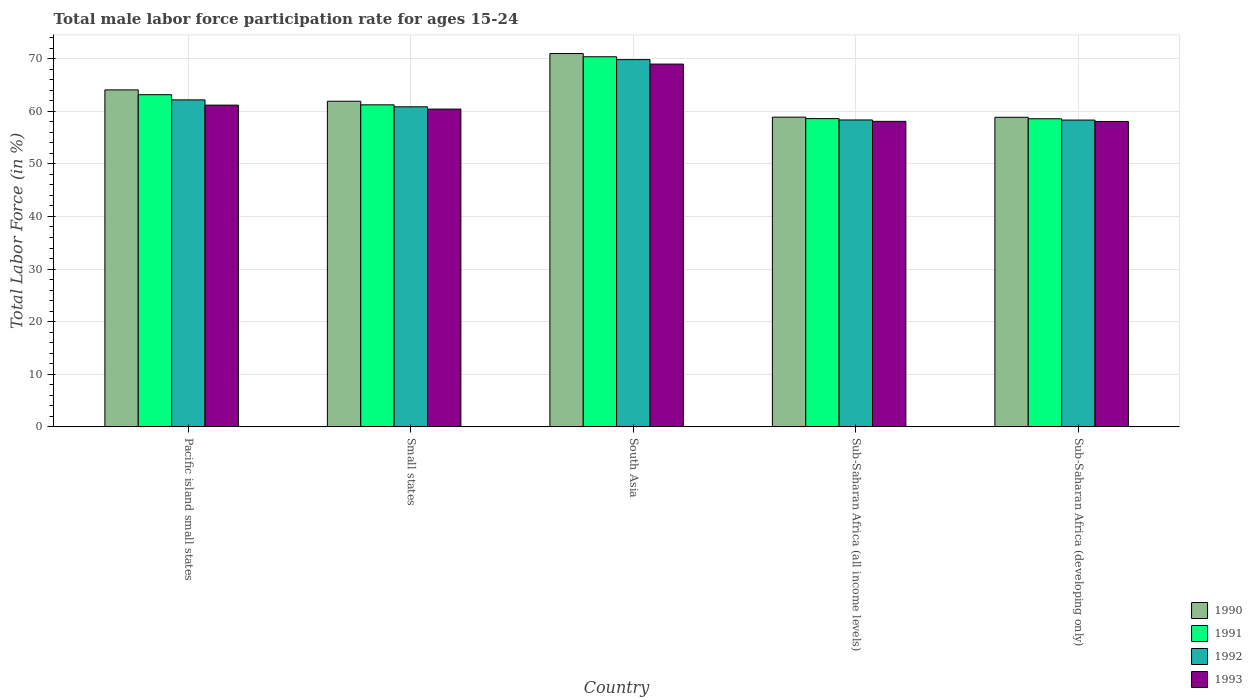How many different coloured bars are there?
Offer a very short reply. 4. Are the number of bars per tick equal to the number of legend labels?
Ensure brevity in your answer.  Yes. How many bars are there on the 5th tick from the left?
Provide a short and direct response. 4. What is the label of the 4th group of bars from the left?
Offer a terse response. Sub-Saharan Africa (all income levels). What is the male labor force participation rate in 1991 in Small states?
Offer a terse response. 61.22. Across all countries, what is the maximum male labor force participation rate in 1992?
Offer a terse response. 69.81. Across all countries, what is the minimum male labor force participation rate in 1991?
Offer a terse response. 58.57. In which country was the male labor force participation rate in 1992 maximum?
Your answer should be compact. South Asia. In which country was the male labor force participation rate in 1990 minimum?
Keep it short and to the point. Sub-Saharan Africa (developing only). What is the total male labor force participation rate in 1991 in the graph?
Offer a very short reply. 311.89. What is the difference between the male labor force participation rate in 1992 in Sub-Saharan Africa (all income levels) and that in Sub-Saharan Africa (developing only)?
Provide a succinct answer. 0.02. What is the difference between the male labor force participation rate in 1991 in South Asia and the male labor force participation rate in 1992 in Sub-Saharan Africa (developing only)?
Provide a short and direct response. 12.04. What is the average male labor force participation rate in 1992 per country?
Your answer should be compact. 61.89. What is the difference between the male labor force participation rate of/in 1990 and male labor force participation rate of/in 1992 in Pacific island small states?
Your answer should be compact. 1.9. What is the ratio of the male labor force participation rate in 1990 in Pacific island small states to that in Small states?
Provide a short and direct response. 1.03. What is the difference between the highest and the second highest male labor force participation rate in 1992?
Provide a short and direct response. -8.97. What is the difference between the highest and the lowest male labor force participation rate in 1992?
Keep it short and to the point. 11.49. Is the sum of the male labor force participation rate in 1991 in Sub-Saharan Africa (all income levels) and Sub-Saharan Africa (developing only) greater than the maximum male labor force participation rate in 1990 across all countries?
Your answer should be compact. Yes. Is it the case that in every country, the sum of the male labor force participation rate in 1990 and male labor force participation rate in 1991 is greater than the sum of male labor force participation rate in 1993 and male labor force participation rate in 1992?
Ensure brevity in your answer.  No. What does the 3rd bar from the right in Pacific island small states represents?
Your answer should be very brief. 1991. Is it the case that in every country, the sum of the male labor force participation rate in 1991 and male labor force participation rate in 1993 is greater than the male labor force participation rate in 1990?
Make the answer very short. Yes. How many bars are there?
Offer a terse response. 20. Does the graph contain grids?
Ensure brevity in your answer.  Yes. Where does the legend appear in the graph?
Provide a succinct answer. Bottom right. How are the legend labels stacked?
Ensure brevity in your answer.  Vertical. What is the title of the graph?
Ensure brevity in your answer.  Total male labor force participation rate for ages 15-24. What is the Total Labor Force (in %) in 1990 in Pacific island small states?
Your answer should be compact. 64.06. What is the Total Labor Force (in %) in 1991 in Pacific island small states?
Make the answer very short. 63.15. What is the Total Labor Force (in %) in 1992 in Pacific island small states?
Keep it short and to the point. 62.16. What is the Total Labor Force (in %) of 1993 in Pacific island small states?
Give a very brief answer. 61.16. What is the Total Labor Force (in %) of 1990 in Small states?
Offer a terse response. 61.9. What is the Total Labor Force (in %) of 1991 in Small states?
Offer a very short reply. 61.22. What is the Total Labor Force (in %) in 1992 in Small states?
Give a very brief answer. 60.84. What is the Total Labor Force (in %) in 1993 in Small states?
Offer a very short reply. 60.41. What is the Total Labor Force (in %) of 1990 in South Asia?
Ensure brevity in your answer.  70.97. What is the Total Labor Force (in %) in 1991 in South Asia?
Your answer should be very brief. 70.36. What is the Total Labor Force (in %) of 1992 in South Asia?
Keep it short and to the point. 69.81. What is the Total Labor Force (in %) in 1993 in South Asia?
Keep it short and to the point. 68.96. What is the Total Labor Force (in %) in 1990 in Sub-Saharan Africa (all income levels)?
Your answer should be very brief. 58.88. What is the Total Labor Force (in %) of 1991 in Sub-Saharan Africa (all income levels)?
Your answer should be compact. 58.6. What is the Total Labor Force (in %) in 1992 in Sub-Saharan Africa (all income levels)?
Ensure brevity in your answer.  58.34. What is the Total Labor Force (in %) of 1993 in Sub-Saharan Africa (all income levels)?
Your response must be concise. 58.08. What is the Total Labor Force (in %) of 1990 in Sub-Saharan Africa (developing only)?
Make the answer very short. 58.85. What is the Total Labor Force (in %) in 1991 in Sub-Saharan Africa (developing only)?
Your response must be concise. 58.57. What is the Total Labor Force (in %) of 1992 in Sub-Saharan Africa (developing only)?
Ensure brevity in your answer.  58.32. What is the Total Labor Force (in %) of 1993 in Sub-Saharan Africa (developing only)?
Provide a short and direct response. 58.06. Across all countries, what is the maximum Total Labor Force (in %) of 1990?
Ensure brevity in your answer.  70.97. Across all countries, what is the maximum Total Labor Force (in %) of 1991?
Ensure brevity in your answer.  70.36. Across all countries, what is the maximum Total Labor Force (in %) in 1992?
Make the answer very short. 69.81. Across all countries, what is the maximum Total Labor Force (in %) in 1993?
Your answer should be compact. 68.96. Across all countries, what is the minimum Total Labor Force (in %) of 1990?
Provide a short and direct response. 58.85. Across all countries, what is the minimum Total Labor Force (in %) in 1991?
Your response must be concise. 58.57. Across all countries, what is the minimum Total Labor Force (in %) of 1992?
Offer a terse response. 58.32. Across all countries, what is the minimum Total Labor Force (in %) in 1993?
Your response must be concise. 58.06. What is the total Total Labor Force (in %) of 1990 in the graph?
Keep it short and to the point. 314.66. What is the total Total Labor Force (in %) of 1991 in the graph?
Your response must be concise. 311.89. What is the total Total Labor Force (in %) in 1992 in the graph?
Offer a very short reply. 309.47. What is the total Total Labor Force (in %) of 1993 in the graph?
Your response must be concise. 306.67. What is the difference between the Total Labor Force (in %) of 1990 in Pacific island small states and that in Small states?
Make the answer very short. 2.15. What is the difference between the Total Labor Force (in %) in 1991 in Pacific island small states and that in Small states?
Make the answer very short. 1.93. What is the difference between the Total Labor Force (in %) in 1992 in Pacific island small states and that in Small states?
Provide a succinct answer. 1.32. What is the difference between the Total Labor Force (in %) in 1993 in Pacific island small states and that in Small states?
Offer a very short reply. 0.75. What is the difference between the Total Labor Force (in %) in 1990 in Pacific island small states and that in South Asia?
Make the answer very short. -6.91. What is the difference between the Total Labor Force (in %) in 1991 in Pacific island small states and that in South Asia?
Offer a terse response. -7.21. What is the difference between the Total Labor Force (in %) of 1992 in Pacific island small states and that in South Asia?
Ensure brevity in your answer.  -7.65. What is the difference between the Total Labor Force (in %) in 1993 in Pacific island small states and that in South Asia?
Provide a succinct answer. -7.8. What is the difference between the Total Labor Force (in %) of 1990 in Pacific island small states and that in Sub-Saharan Africa (all income levels)?
Make the answer very short. 5.18. What is the difference between the Total Labor Force (in %) of 1991 in Pacific island small states and that in Sub-Saharan Africa (all income levels)?
Make the answer very short. 4.55. What is the difference between the Total Labor Force (in %) of 1992 in Pacific island small states and that in Sub-Saharan Africa (all income levels)?
Your answer should be compact. 3.82. What is the difference between the Total Labor Force (in %) of 1993 in Pacific island small states and that in Sub-Saharan Africa (all income levels)?
Make the answer very short. 3.08. What is the difference between the Total Labor Force (in %) in 1990 in Pacific island small states and that in Sub-Saharan Africa (developing only)?
Provide a short and direct response. 5.21. What is the difference between the Total Labor Force (in %) of 1991 in Pacific island small states and that in Sub-Saharan Africa (developing only)?
Your response must be concise. 4.57. What is the difference between the Total Labor Force (in %) of 1992 in Pacific island small states and that in Sub-Saharan Africa (developing only)?
Make the answer very short. 3.84. What is the difference between the Total Labor Force (in %) in 1993 in Pacific island small states and that in Sub-Saharan Africa (developing only)?
Offer a terse response. 3.1. What is the difference between the Total Labor Force (in %) of 1990 in Small states and that in South Asia?
Give a very brief answer. -9.06. What is the difference between the Total Labor Force (in %) in 1991 in Small states and that in South Asia?
Provide a succinct answer. -9.14. What is the difference between the Total Labor Force (in %) in 1992 in Small states and that in South Asia?
Your response must be concise. -8.97. What is the difference between the Total Labor Force (in %) in 1993 in Small states and that in South Asia?
Your answer should be very brief. -8.55. What is the difference between the Total Labor Force (in %) in 1990 in Small states and that in Sub-Saharan Africa (all income levels)?
Give a very brief answer. 3.03. What is the difference between the Total Labor Force (in %) of 1991 in Small states and that in Sub-Saharan Africa (all income levels)?
Give a very brief answer. 2.62. What is the difference between the Total Labor Force (in %) in 1992 in Small states and that in Sub-Saharan Africa (all income levels)?
Give a very brief answer. 2.5. What is the difference between the Total Labor Force (in %) in 1993 in Small states and that in Sub-Saharan Africa (all income levels)?
Make the answer very short. 2.33. What is the difference between the Total Labor Force (in %) of 1990 in Small states and that in Sub-Saharan Africa (developing only)?
Offer a very short reply. 3.05. What is the difference between the Total Labor Force (in %) of 1991 in Small states and that in Sub-Saharan Africa (developing only)?
Provide a succinct answer. 2.64. What is the difference between the Total Labor Force (in %) of 1992 in Small states and that in Sub-Saharan Africa (developing only)?
Provide a short and direct response. 2.52. What is the difference between the Total Labor Force (in %) in 1993 in Small states and that in Sub-Saharan Africa (developing only)?
Make the answer very short. 2.35. What is the difference between the Total Labor Force (in %) in 1990 in South Asia and that in Sub-Saharan Africa (all income levels)?
Give a very brief answer. 12.09. What is the difference between the Total Labor Force (in %) in 1991 in South Asia and that in Sub-Saharan Africa (all income levels)?
Ensure brevity in your answer.  11.76. What is the difference between the Total Labor Force (in %) of 1992 in South Asia and that in Sub-Saharan Africa (all income levels)?
Offer a very short reply. 11.47. What is the difference between the Total Labor Force (in %) of 1993 in South Asia and that in Sub-Saharan Africa (all income levels)?
Your answer should be compact. 10.89. What is the difference between the Total Labor Force (in %) of 1990 in South Asia and that in Sub-Saharan Africa (developing only)?
Provide a short and direct response. 12.11. What is the difference between the Total Labor Force (in %) of 1991 in South Asia and that in Sub-Saharan Africa (developing only)?
Ensure brevity in your answer.  11.78. What is the difference between the Total Labor Force (in %) of 1992 in South Asia and that in Sub-Saharan Africa (developing only)?
Make the answer very short. 11.49. What is the difference between the Total Labor Force (in %) of 1993 in South Asia and that in Sub-Saharan Africa (developing only)?
Your answer should be very brief. 10.91. What is the difference between the Total Labor Force (in %) of 1990 in Sub-Saharan Africa (all income levels) and that in Sub-Saharan Africa (developing only)?
Ensure brevity in your answer.  0.02. What is the difference between the Total Labor Force (in %) of 1991 in Sub-Saharan Africa (all income levels) and that in Sub-Saharan Africa (developing only)?
Give a very brief answer. 0.02. What is the difference between the Total Labor Force (in %) of 1992 in Sub-Saharan Africa (all income levels) and that in Sub-Saharan Africa (developing only)?
Your answer should be very brief. 0.02. What is the difference between the Total Labor Force (in %) in 1993 in Sub-Saharan Africa (all income levels) and that in Sub-Saharan Africa (developing only)?
Give a very brief answer. 0.02. What is the difference between the Total Labor Force (in %) of 1990 in Pacific island small states and the Total Labor Force (in %) of 1991 in Small states?
Your response must be concise. 2.84. What is the difference between the Total Labor Force (in %) in 1990 in Pacific island small states and the Total Labor Force (in %) in 1992 in Small states?
Provide a succinct answer. 3.22. What is the difference between the Total Labor Force (in %) in 1990 in Pacific island small states and the Total Labor Force (in %) in 1993 in Small states?
Offer a very short reply. 3.65. What is the difference between the Total Labor Force (in %) in 1991 in Pacific island small states and the Total Labor Force (in %) in 1992 in Small states?
Keep it short and to the point. 2.3. What is the difference between the Total Labor Force (in %) in 1991 in Pacific island small states and the Total Labor Force (in %) in 1993 in Small states?
Provide a short and direct response. 2.74. What is the difference between the Total Labor Force (in %) in 1992 in Pacific island small states and the Total Labor Force (in %) in 1993 in Small states?
Your answer should be compact. 1.75. What is the difference between the Total Labor Force (in %) of 1990 in Pacific island small states and the Total Labor Force (in %) of 1991 in South Asia?
Offer a very short reply. -6.3. What is the difference between the Total Labor Force (in %) in 1990 in Pacific island small states and the Total Labor Force (in %) in 1992 in South Asia?
Offer a very short reply. -5.75. What is the difference between the Total Labor Force (in %) in 1990 in Pacific island small states and the Total Labor Force (in %) in 1993 in South Asia?
Provide a short and direct response. -4.9. What is the difference between the Total Labor Force (in %) in 1991 in Pacific island small states and the Total Labor Force (in %) in 1992 in South Asia?
Offer a very short reply. -6.66. What is the difference between the Total Labor Force (in %) of 1991 in Pacific island small states and the Total Labor Force (in %) of 1993 in South Asia?
Make the answer very short. -5.82. What is the difference between the Total Labor Force (in %) of 1992 in Pacific island small states and the Total Labor Force (in %) of 1993 in South Asia?
Make the answer very short. -6.8. What is the difference between the Total Labor Force (in %) in 1990 in Pacific island small states and the Total Labor Force (in %) in 1991 in Sub-Saharan Africa (all income levels)?
Make the answer very short. 5.46. What is the difference between the Total Labor Force (in %) of 1990 in Pacific island small states and the Total Labor Force (in %) of 1992 in Sub-Saharan Africa (all income levels)?
Your answer should be compact. 5.72. What is the difference between the Total Labor Force (in %) of 1990 in Pacific island small states and the Total Labor Force (in %) of 1993 in Sub-Saharan Africa (all income levels)?
Offer a terse response. 5.98. What is the difference between the Total Labor Force (in %) in 1991 in Pacific island small states and the Total Labor Force (in %) in 1992 in Sub-Saharan Africa (all income levels)?
Your answer should be very brief. 4.8. What is the difference between the Total Labor Force (in %) of 1991 in Pacific island small states and the Total Labor Force (in %) of 1993 in Sub-Saharan Africa (all income levels)?
Provide a short and direct response. 5.07. What is the difference between the Total Labor Force (in %) in 1992 in Pacific island small states and the Total Labor Force (in %) in 1993 in Sub-Saharan Africa (all income levels)?
Your answer should be compact. 4.08. What is the difference between the Total Labor Force (in %) of 1990 in Pacific island small states and the Total Labor Force (in %) of 1991 in Sub-Saharan Africa (developing only)?
Provide a succinct answer. 5.48. What is the difference between the Total Labor Force (in %) in 1990 in Pacific island small states and the Total Labor Force (in %) in 1992 in Sub-Saharan Africa (developing only)?
Give a very brief answer. 5.74. What is the difference between the Total Labor Force (in %) in 1990 in Pacific island small states and the Total Labor Force (in %) in 1993 in Sub-Saharan Africa (developing only)?
Give a very brief answer. 6. What is the difference between the Total Labor Force (in %) of 1991 in Pacific island small states and the Total Labor Force (in %) of 1992 in Sub-Saharan Africa (developing only)?
Your answer should be compact. 4.83. What is the difference between the Total Labor Force (in %) in 1991 in Pacific island small states and the Total Labor Force (in %) in 1993 in Sub-Saharan Africa (developing only)?
Provide a succinct answer. 5.09. What is the difference between the Total Labor Force (in %) in 1992 in Pacific island small states and the Total Labor Force (in %) in 1993 in Sub-Saharan Africa (developing only)?
Offer a terse response. 4.1. What is the difference between the Total Labor Force (in %) of 1990 in Small states and the Total Labor Force (in %) of 1991 in South Asia?
Keep it short and to the point. -8.45. What is the difference between the Total Labor Force (in %) in 1990 in Small states and the Total Labor Force (in %) in 1992 in South Asia?
Provide a succinct answer. -7.9. What is the difference between the Total Labor Force (in %) of 1990 in Small states and the Total Labor Force (in %) of 1993 in South Asia?
Make the answer very short. -7.06. What is the difference between the Total Labor Force (in %) in 1991 in Small states and the Total Labor Force (in %) in 1992 in South Asia?
Ensure brevity in your answer.  -8.59. What is the difference between the Total Labor Force (in %) in 1991 in Small states and the Total Labor Force (in %) in 1993 in South Asia?
Offer a terse response. -7.75. What is the difference between the Total Labor Force (in %) in 1992 in Small states and the Total Labor Force (in %) in 1993 in South Asia?
Your response must be concise. -8.12. What is the difference between the Total Labor Force (in %) of 1990 in Small states and the Total Labor Force (in %) of 1991 in Sub-Saharan Africa (all income levels)?
Ensure brevity in your answer.  3.31. What is the difference between the Total Labor Force (in %) in 1990 in Small states and the Total Labor Force (in %) in 1992 in Sub-Saharan Africa (all income levels)?
Provide a succinct answer. 3.56. What is the difference between the Total Labor Force (in %) of 1990 in Small states and the Total Labor Force (in %) of 1993 in Sub-Saharan Africa (all income levels)?
Ensure brevity in your answer.  3.83. What is the difference between the Total Labor Force (in %) in 1991 in Small states and the Total Labor Force (in %) in 1992 in Sub-Saharan Africa (all income levels)?
Ensure brevity in your answer.  2.88. What is the difference between the Total Labor Force (in %) of 1991 in Small states and the Total Labor Force (in %) of 1993 in Sub-Saharan Africa (all income levels)?
Provide a succinct answer. 3.14. What is the difference between the Total Labor Force (in %) of 1992 in Small states and the Total Labor Force (in %) of 1993 in Sub-Saharan Africa (all income levels)?
Give a very brief answer. 2.77. What is the difference between the Total Labor Force (in %) in 1990 in Small states and the Total Labor Force (in %) in 1991 in Sub-Saharan Africa (developing only)?
Keep it short and to the point. 3.33. What is the difference between the Total Labor Force (in %) in 1990 in Small states and the Total Labor Force (in %) in 1992 in Sub-Saharan Africa (developing only)?
Your answer should be very brief. 3.58. What is the difference between the Total Labor Force (in %) of 1990 in Small states and the Total Labor Force (in %) of 1993 in Sub-Saharan Africa (developing only)?
Offer a very short reply. 3.85. What is the difference between the Total Labor Force (in %) in 1991 in Small states and the Total Labor Force (in %) in 1992 in Sub-Saharan Africa (developing only)?
Keep it short and to the point. 2.9. What is the difference between the Total Labor Force (in %) of 1991 in Small states and the Total Labor Force (in %) of 1993 in Sub-Saharan Africa (developing only)?
Provide a succinct answer. 3.16. What is the difference between the Total Labor Force (in %) in 1992 in Small states and the Total Labor Force (in %) in 1993 in Sub-Saharan Africa (developing only)?
Offer a terse response. 2.79. What is the difference between the Total Labor Force (in %) of 1990 in South Asia and the Total Labor Force (in %) of 1991 in Sub-Saharan Africa (all income levels)?
Offer a very short reply. 12.37. What is the difference between the Total Labor Force (in %) of 1990 in South Asia and the Total Labor Force (in %) of 1992 in Sub-Saharan Africa (all income levels)?
Give a very brief answer. 12.63. What is the difference between the Total Labor Force (in %) of 1990 in South Asia and the Total Labor Force (in %) of 1993 in Sub-Saharan Africa (all income levels)?
Provide a short and direct response. 12.89. What is the difference between the Total Labor Force (in %) in 1991 in South Asia and the Total Labor Force (in %) in 1992 in Sub-Saharan Africa (all income levels)?
Keep it short and to the point. 12.02. What is the difference between the Total Labor Force (in %) in 1991 in South Asia and the Total Labor Force (in %) in 1993 in Sub-Saharan Africa (all income levels)?
Your answer should be very brief. 12.28. What is the difference between the Total Labor Force (in %) in 1992 in South Asia and the Total Labor Force (in %) in 1993 in Sub-Saharan Africa (all income levels)?
Give a very brief answer. 11.73. What is the difference between the Total Labor Force (in %) in 1990 in South Asia and the Total Labor Force (in %) in 1991 in Sub-Saharan Africa (developing only)?
Make the answer very short. 12.39. What is the difference between the Total Labor Force (in %) of 1990 in South Asia and the Total Labor Force (in %) of 1992 in Sub-Saharan Africa (developing only)?
Give a very brief answer. 12.65. What is the difference between the Total Labor Force (in %) of 1990 in South Asia and the Total Labor Force (in %) of 1993 in Sub-Saharan Africa (developing only)?
Your answer should be compact. 12.91. What is the difference between the Total Labor Force (in %) in 1991 in South Asia and the Total Labor Force (in %) in 1992 in Sub-Saharan Africa (developing only)?
Make the answer very short. 12.04. What is the difference between the Total Labor Force (in %) of 1991 in South Asia and the Total Labor Force (in %) of 1993 in Sub-Saharan Africa (developing only)?
Offer a very short reply. 12.3. What is the difference between the Total Labor Force (in %) in 1992 in South Asia and the Total Labor Force (in %) in 1993 in Sub-Saharan Africa (developing only)?
Your answer should be very brief. 11.75. What is the difference between the Total Labor Force (in %) in 1990 in Sub-Saharan Africa (all income levels) and the Total Labor Force (in %) in 1991 in Sub-Saharan Africa (developing only)?
Your answer should be compact. 0.3. What is the difference between the Total Labor Force (in %) in 1990 in Sub-Saharan Africa (all income levels) and the Total Labor Force (in %) in 1992 in Sub-Saharan Africa (developing only)?
Your answer should be compact. 0.56. What is the difference between the Total Labor Force (in %) in 1990 in Sub-Saharan Africa (all income levels) and the Total Labor Force (in %) in 1993 in Sub-Saharan Africa (developing only)?
Your answer should be very brief. 0.82. What is the difference between the Total Labor Force (in %) in 1991 in Sub-Saharan Africa (all income levels) and the Total Labor Force (in %) in 1992 in Sub-Saharan Africa (developing only)?
Ensure brevity in your answer.  0.28. What is the difference between the Total Labor Force (in %) in 1991 in Sub-Saharan Africa (all income levels) and the Total Labor Force (in %) in 1993 in Sub-Saharan Africa (developing only)?
Provide a succinct answer. 0.54. What is the difference between the Total Labor Force (in %) of 1992 in Sub-Saharan Africa (all income levels) and the Total Labor Force (in %) of 1993 in Sub-Saharan Africa (developing only)?
Make the answer very short. 0.28. What is the average Total Labor Force (in %) in 1990 per country?
Offer a very short reply. 62.93. What is the average Total Labor Force (in %) of 1991 per country?
Make the answer very short. 62.38. What is the average Total Labor Force (in %) of 1992 per country?
Ensure brevity in your answer.  61.89. What is the average Total Labor Force (in %) of 1993 per country?
Ensure brevity in your answer.  61.33. What is the difference between the Total Labor Force (in %) in 1990 and Total Labor Force (in %) in 1991 in Pacific island small states?
Ensure brevity in your answer.  0.91. What is the difference between the Total Labor Force (in %) of 1990 and Total Labor Force (in %) of 1992 in Pacific island small states?
Offer a terse response. 1.9. What is the difference between the Total Labor Force (in %) in 1990 and Total Labor Force (in %) in 1993 in Pacific island small states?
Give a very brief answer. 2.9. What is the difference between the Total Labor Force (in %) of 1991 and Total Labor Force (in %) of 1992 in Pacific island small states?
Your answer should be very brief. 0.99. What is the difference between the Total Labor Force (in %) in 1991 and Total Labor Force (in %) in 1993 in Pacific island small states?
Keep it short and to the point. 1.98. What is the difference between the Total Labor Force (in %) of 1992 and Total Labor Force (in %) of 1993 in Pacific island small states?
Offer a very short reply. 1. What is the difference between the Total Labor Force (in %) of 1990 and Total Labor Force (in %) of 1991 in Small states?
Offer a very short reply. 0.69. What is the difference between the Total Labor Force (in %) of 1990 and Total Labor Force (in %) of 1992 in Small states?
Give a very brief answer. 1.06. What is the difference between the Total Labor Force (in %) in 1990 and Total Labor Force (in %) in 1993 in Small states?
Give a very brief answer. 1.5. What is the difference between the Total Labor Force (in %) in 1991 and Total Labor Force (in %) in 1992 in Small states?
Keep it short and to the point. 0.37. What is the difference between the Total Labor Force (in %) of 1991 and Total Labor Force (in %) of 1993 in Small states?
Your answer should be compact. 0.81. What is the difference between the Total Labor Force (in %) in 1992 and Total Labor Force (in %) in 1993 in Small states?
Provide a succinct answer. 0.43. What is the difference between the Total Labor Force (in %) in 1990 and Total Labor Force (in %) in 1991 in South Asia?
Your answer should be very brief. 0.61. What is the difference between the Total Labor Force (in %) in 1990 and Total Labor Force (in %) in 1992 in South Asia?
Your answer should be very brief. 1.16. What is the difference between the Total Labor Force (in %) of 1990 and Total Labor Force (in %) of 1993 in South Asia?
Ensure brevity in your answer.  2. What is the difference between the Total Labor Force (in %) of 1991 and Total Labor Force (in %) of 1992 in South Asia?
Keep it short and to the point. 0.55. What is the difference between the Total Labor Force (in %) of 1991 and Total Labor Force (in %) of 1993 in South Asia?
Your answer should be very brief. 1.39. What is the difference between the Total Labor Force (in %) of 1992 and Total Labor Force (in %) of 1993 in South Asia?
Ensure brevity in your answer.  0.85. What is the difference between the Total Labor Force (in %) in 1990 and Total Labor Force (in %) in 1991 in Sub-Saharan Africa (all income levels)?
Your response must be concise. 0.28. What is the difference between the Total Labor Force (in %) in 1990 and Total Labor Force (in %) in 1992 in Sub-Saharan Africa (all income levels)?
Your answer should be compact. 0.53. What is the difference between the Total Labor Force (in %) of 1990 and Total Labor Force (in %) of 1993 in Sub-Saharan Africa (all income levels)?
Your answer should be compact. 0.8. What is the difference between the Total Labor Force (in %) in 1991 and Total Labor Force (in %) in 1992 in Sub-Saharan Africa (all income levels)?
Offer a very short reply. 0.26. What is the difference between the Total Labor Force (in %) in 1991 and Total Labor Force (in %) in 1993 in Sub-Saharan Africa (all income levels)?
Make the answer very short. 0.52. What is the difference between the Total Labor Force (in %) of 1992 and Total Labor Force (in %) of 1993 in Sub-Saharan Africa (all income levels)?
Make the answer very short. 0.26. What is the difference between the Total Labor Force (in %) in 1990 and Total Labor Force (in %) in 1991 in Sub-Saharan Africa (developing only)?
Provide a succinct answer. 0.28. What is the difference between the Total Labor Force (in %) in 1990 and Total Labor Force (in %) in 1992 in Sub-Saharan Africa (developing only)?
Provide a succinct answer. 0.53. What is the difference between the Total Labor Force (in %) in 1990 and Total Labor Force (in %) in 1993 in Sub-Saharan Africa (developing only)?
Ensure brevity in your answer.  0.8. What is the difference between the Total Labor Force (in %) of 1991 and Total Labor Force (in %) of 1992 in Sub-Saharan Africa (developing only)?
Your response must be concise. 0.25. What is the difference between the Total Labor Force (in %) in 1991 and Total Labor Force (in %) in 1993 in Sub-Saharan Africa (developing only)?
Your answer should be compact. 0.52. What is the difference between the Total Labor Force (in %) of 1992 and Total Labor Force (in %) of 1993 in Sub-Saharan Africa (developing only)?
Offer a very short reply. 0.26. What is the ratio of the Total Labor Force (in %) in 1990 in Pacific island small states to that in Small states?
Offer a very short reply. 1.03. What is the ratio of the Total Labor Force (in %) of 1991 in Pacific island small states to that in Small states?
Offer a very short reply. 1.03. What is the ratio of the Total Labor Force (in %) in 1992 in Pacific island small states to that in Small states?
Give a very brief answer. 1.02. What is the ratio of the Total Labor Force (in %) of 1993 in Pacific island small states to that in Small states?
Ensure brevity in your answer.  1.01. What is the ratio of the Total Labor Force (in %) in 1990 in Pacific island small states to that in South Asia?
Offer a terse response. 0.9. What is the ratio of the Total Labor Force (in %) of 1991 in Pacific island small states to that in South Asia?
Your answer should be compact. 0.9. What is the ratio of the Total Labor Force (in %) of 1992 in Pacific island small states to that in South Asia?
Provide a short and direct response. 0.89. What is the ratio of the Total Labor Force (in %) of 1993 in Pacific island small states to that in South Asia?
Your answer should be very brief. 0.89. What is the ratio of the Total Labor Force (in %) of 1990 in Pacific island small states to that in Sub-Saharan Africa (all income levels)?
Your response must be concise. 1.09. What is the ratio of the Total Labor Force (in %) of 1991 in Pacific island small states to that in Sub-Saharan Africa (all income levels)?
Ensure brevity in your answer.  1.08. What is the ratio of the Total Labor Force (in %) in 1992 in Pacific island small states to that in Sub-Saharan Africa (all income levels)?
Offer a very short reply. 1.07. What is the ratio of the Total Labor Force (in %) of 1993 in Pacific island small states to that in Sub-Saharan Africa (all income levels)?
Give a very brief answer. 1.05. What is the ratio of the Total Labor Force (in %) of 1990 in Pacific island small states to that in Sub-Saharan Africa (developing only)?
Make the answer very short. 1.09. What is the ratio of the Total Labor Force (in %) in 1991 in Pacific island small states to that in Sub-Saharan Africa (developing only)?
Provide a succinct answer. 1.08. What is the ratio of the Total Labor Force (in %) of 1992 in Pacific island small states to that in Sub-Saharan Africa (developing only)?
Offer a terse response. 1.07. What is the ratio of the Total Labor Force (in %) of 1993 in Pacific island small states to that in Sub-Saharan Africa (developing only)?
Ensure brevity in your answer.  1.05. What is the ratio of the Total Labor Force (in %) in 1990 in Small states to that in South Asia?
Your response must be concise. 0.87. What is the ratio of the Total Labor Force (in %) of 1991 in Small states to that in South Asia?
Ensure brevity in your answer.  0.87. What is the ratio of the Total Labor Force (in %) in 1992 in Small states to that in South Asia?
Your response must be concise. 0.87. What is the ratio of the Total Labor Force (in %) in 1993 in Small states to that in South Asia?
Provide a succinct answer. 0.88. What is the ratio of the Total Labor Force (in %) of 1990 in Small states to that in Sub-Saharan Africa (all income levels)?
Make the answer very short. 1.05. What is the ratio of the Total Labor Force (in %) of 1991 in Small states to that in Sub-Saharan Africa (all income levels)?
Your answer should be compact. 1.04. What is the ratio of the Total Labor Force (in %) in 1992 in Small states to that in Sub-Saharan Africa (all income levels)?
Your answer should be compact. 1.04. What is the ratio of the Total Labor Force (in %) of 1993 in Small states to that in Sub-Saharan Africa (all income levels)?
Your response must be concise. 1.04. What is the ratio of the Total Labor Force (in %) in 1990 in Small states to that in Sub-Saharan Africa (developing only)?
Keep it short and to the point. 1.05. What is the ratio of the Total Labor Force (in %) of 1991 in Small states to that in Sub-Saharan Africa (developing only)?
Make the answer very short. 1.05. What is the ratio of the Total Labor Force (in %) in 1992 in Small states to that in Sub-Saharan Africa (developing only)?
Give a very brief answer. 1.04. What is the ratio of the Total Labor Force (in %) of 1993 in Small states to that in Sub-Saharan Africa (developing only)?
Your response must be concise. 1.04. What is the ratio of the Total Labor Force (in %) of 1990 in South Asia to that in Sub-Saharan Africa (all income levels)?
Your answer should be very brief. 1.21. What is the ratio of the Total Labor Force (in %) in 1991 in South Asia to that in Sub-Saharan Africa (all income levels)?
Ensure brevity in your answer.  1.2. What is the ratio of the Total Labor Force (in %) in 1992 in South Asia to that in Sub-Saharan Africa (all income levels)?
Ensure brevity in your answer.  1.2. What is the ratio of the Total Labor Force (in %) in 1993 in South Asia to that in Sub-Saharan Africa (all income levels)?
Offer a terse response. 1.19. What is the ratio of the Total Labor Force (in %) in 1990 in South Asia to that in Sub-Saharan Africa (developing only)?
Give a very brief answer. 1.21. What is the ratio of the Total Labor Force (in %) of 1991 in South Asia to that in Sub-Saharan Africa (developing only)?
Give a very brief answer. 1.2. What is the ratio of the Total Labor Force (in %) of 1992 in South Asia to that in Sub-Saharan Africa (developing only)?
Make the answer very short. 1.2. What is the ratio of the Total Labor Force (in %) of 1993 in South Asia to that in Sub-Saharan Africa (developing only)?
Offer a terse response. 1.19. What is the difference between the highest and the second highest Total Labor Force (in %) in 1990?
Your answer should be very brief. 6.91. What is the difference between the highest and the second highest Total Labor Force (in %) of 1991?
Your answer should be very brief. 7.21. What is the difference between the highest and the second highest Total Labor Force (in %) in 1992?
Your response must be concise. 7.65. What is the difference between the highest and the second highest Total Labor Force (in %) in 1993?
Provide a succinct answer. 7.8. What is the difference between the highest and the lowest Total Labor Force (in %) of 1990?
Your response must be concise. 12.11. What is the difference between the highest and the lowest Total Labor Force (in %) of 1991?
Offer a very short reply. 11.78. What is the difference between the highest and the lowest Total Labor Force (in %) in 1992?
Your answer should be very brief. 11.49. What is the difference between the highest and the lowest Total Labor Force (in %) in 1993?
Your answer should be very brief. 10.91. 